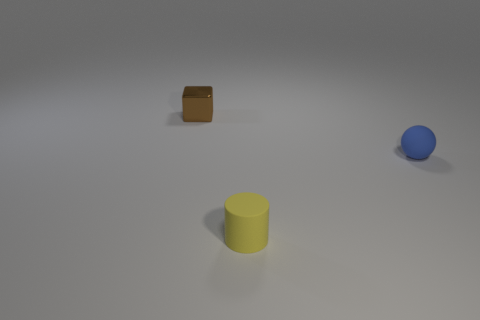Do the brown metal cube and the blue matte sphere have the same size? yes 